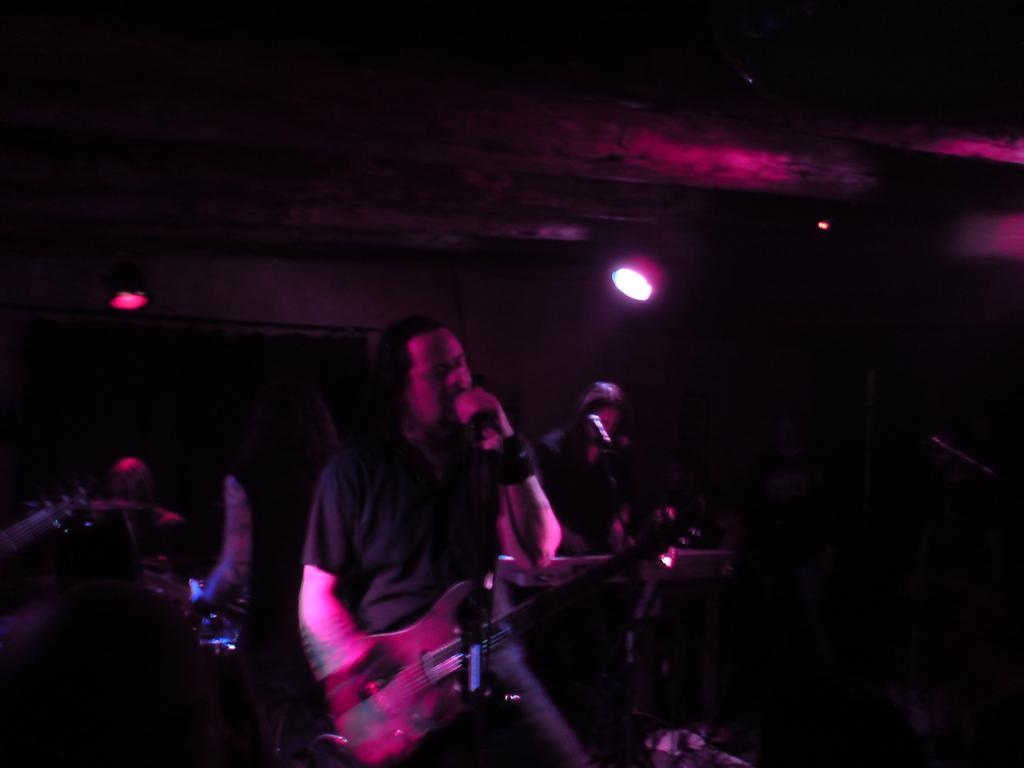How many people are in the image? There is a group of people in the image. What is one person in the group doing? One person is holding a guitar. What is the person with the guitar doing? The person with the guitar is singing a song. What can be seen in the background of the image? There are lightnings visible in the background of the image. What type of pets are present in the image? There are no pets visible in the image. How far away is the person with the guitar from the lightning in the image? The distance between the person with the guitar and the lightning cannot be determined from the image. 